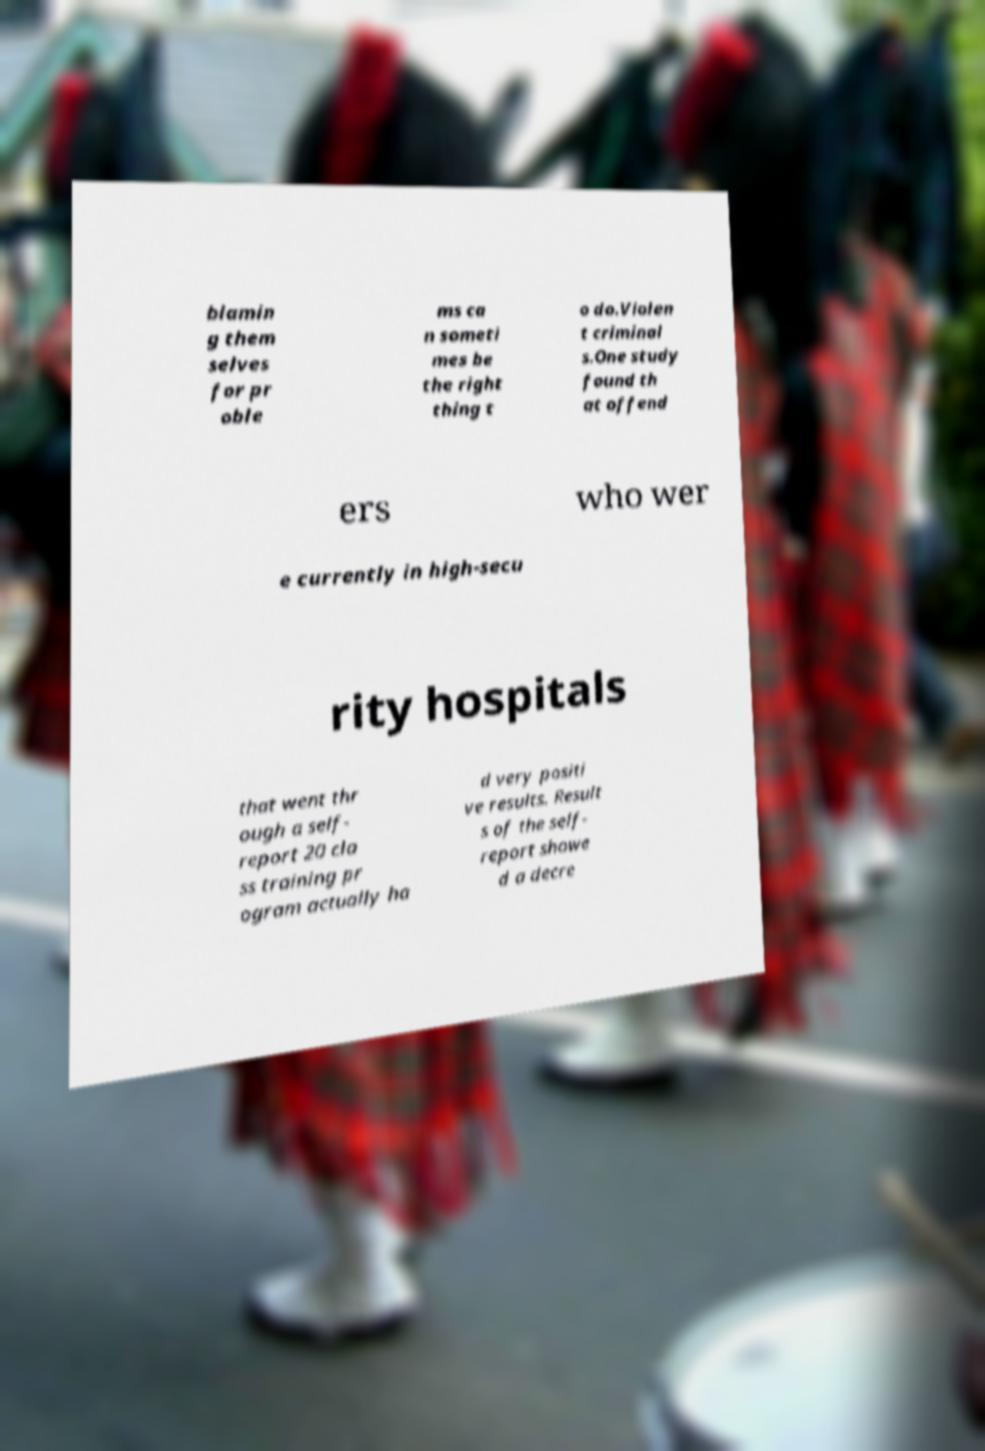Can you accurately transcribe the text from the provided image for me? blamin g them selves for pr oble ms ca n someti mes be the right thing t o do.Violen t criminal s.One study found th at offend ers who wer e currently in high-secu rity hospitals that went thr ough a self- report 20 cla ss training pr ogram actually ha d very positi ve results. Result s of the self- report showe d a decre 